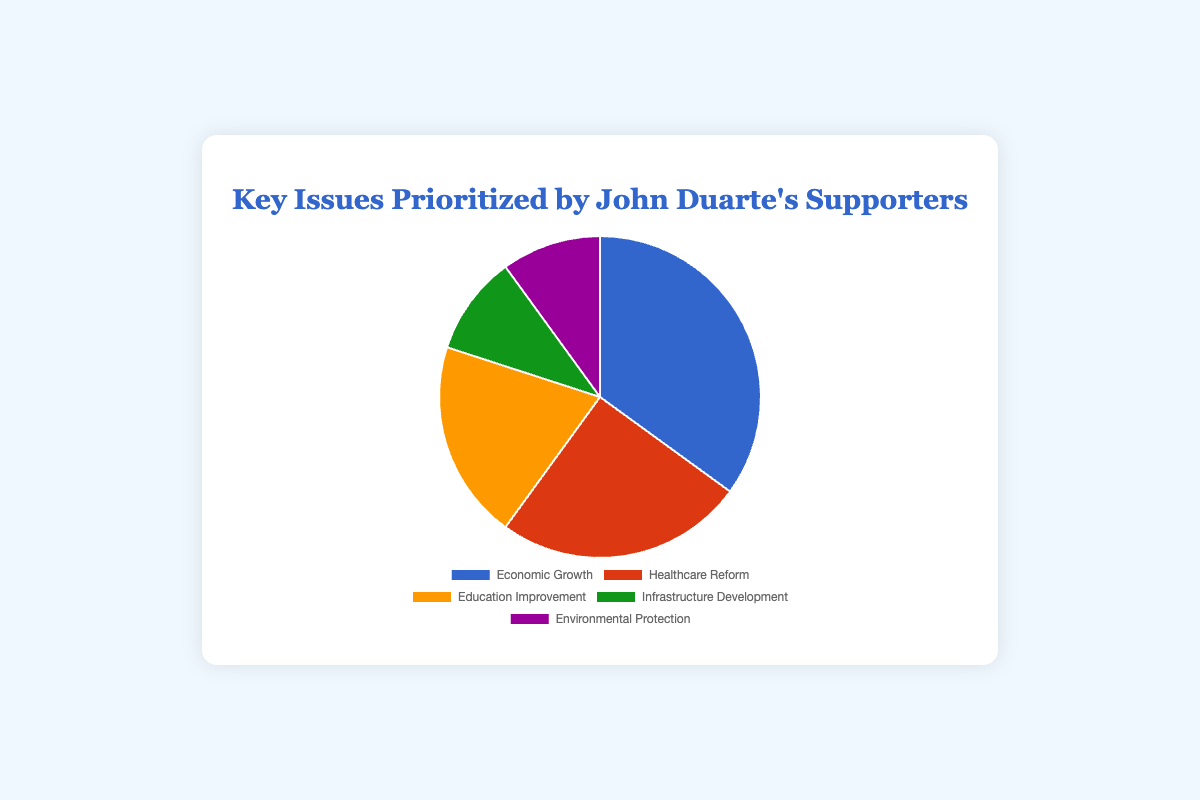What percentage of John Duarte's supporters prioritize Healthcare Reform? The section labeled 'Healthcare Reform' is 25% of the pie chart.
Answer: 25% Which key issue is the most prioritized by John Duarte's supporters? The 'Economic Growth' section occupies the largest portion of the pie chart at 35%.
Answer: Economic Growth How much more percentage of supporters prioritize Economic Growth over Infrastructure Development? Economic Growth is at 35% while Infrastructure Development is at 10%. The difference is 35% - 10% = 25%.
Answer: 25% Are there any key issues that have equal prioritization percentages among John Duarte's supporters? Both 'Infrastructure Development' and 'Environmental Protection' sections each take up 10% of the pie chart.
Answer: Yes What is the total percentage of supporters who prioritize Education Improvement and Healthcare Reform combined? Education Improvement is 20% and Healthcare Reform is 25%. Adding both gives 20% + 25% = 45%.
Answer: 45% Which key issue is represented by the orange section? The pie chart shows that the orange section corresponds to 'Education Improvement'.
Answer: Education Improvement What percentage of John Duarte's supporters do not prioritize Environmental Protection? Environmental Protection represents 10%. Hence, 100% - 10% = 90% of supporters do not prioritize it.
Answer: 90% Compare the percentage of supporters who prioritize Education Improvement with those who prioritize Infrastructure Development. Education Improvement is 20%, and Infrastructure Development is 10%. Education Improvement is double the percentage of Infrastructure Development.
Answer: Education Improvement is double What is the percentage difference between the most prioritized issue and the least prioritized issue? The most prioritized issue is Economic Growth at 35%, and the least prioritized issues are Infrastructure Development and Environmental Protection at 10%. The difference is 35% - 10% = 25%.
Answer: 25% What percentage of John Duarte's supporters prioritize issues other than Economic Growth? Economic Growth is prioritized by 35%, so the remaining percentage is 100% - 35% = 65%.
Answer: 65% 